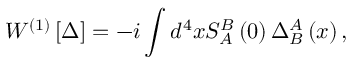Convert formula to latex. <formula><loc_0><loc_0><loc_500><loc_500>W ^ { \left ( 1 \right ) } \left [ \Delta \right ] = - i \int d ^ { 4 } x S _ { A } ^ { B } \left ( 0 \right ) \Delta _ { B } ^ { A } \left ( x \right ) ,</formula> 